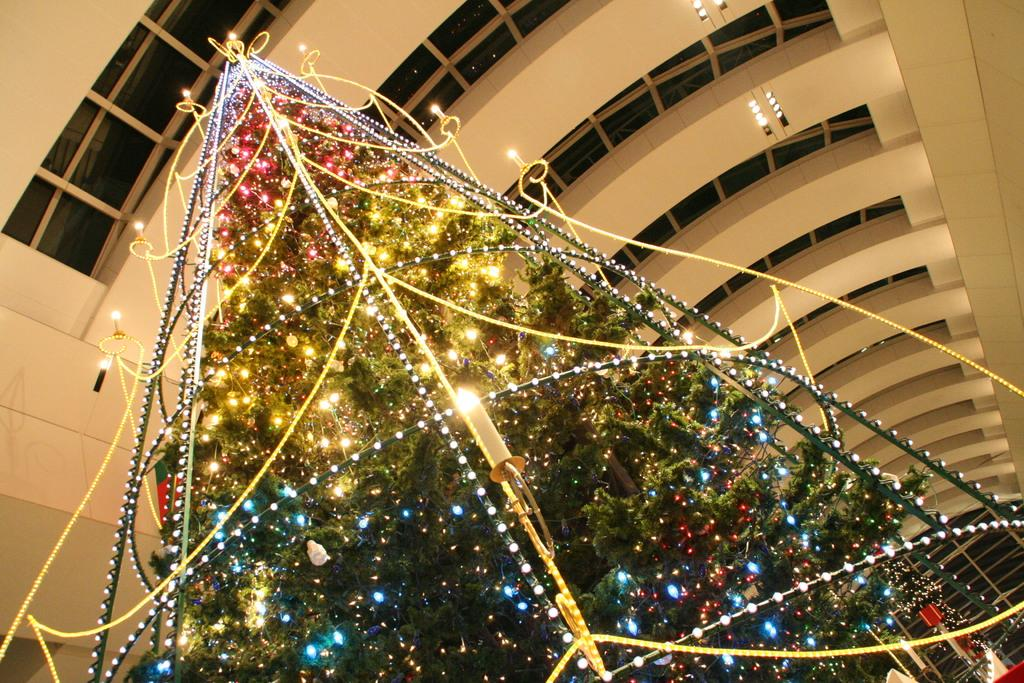What is the main subject in the center of the image? There is a Christmas tree with lights in the center of the image. What part of the room can be seen at the top of the image? The ceiling is visible at the top of the image. Can you describe the lighting in the image? There are lights in the image, including those on the Christmas tree. What type of teaching is taking place in the image? There is no teaching taking place in the image; it features a Christmas tree with lights and a visible ceiling. Can you see a lamp in the image? There is no lamp present in the image. 